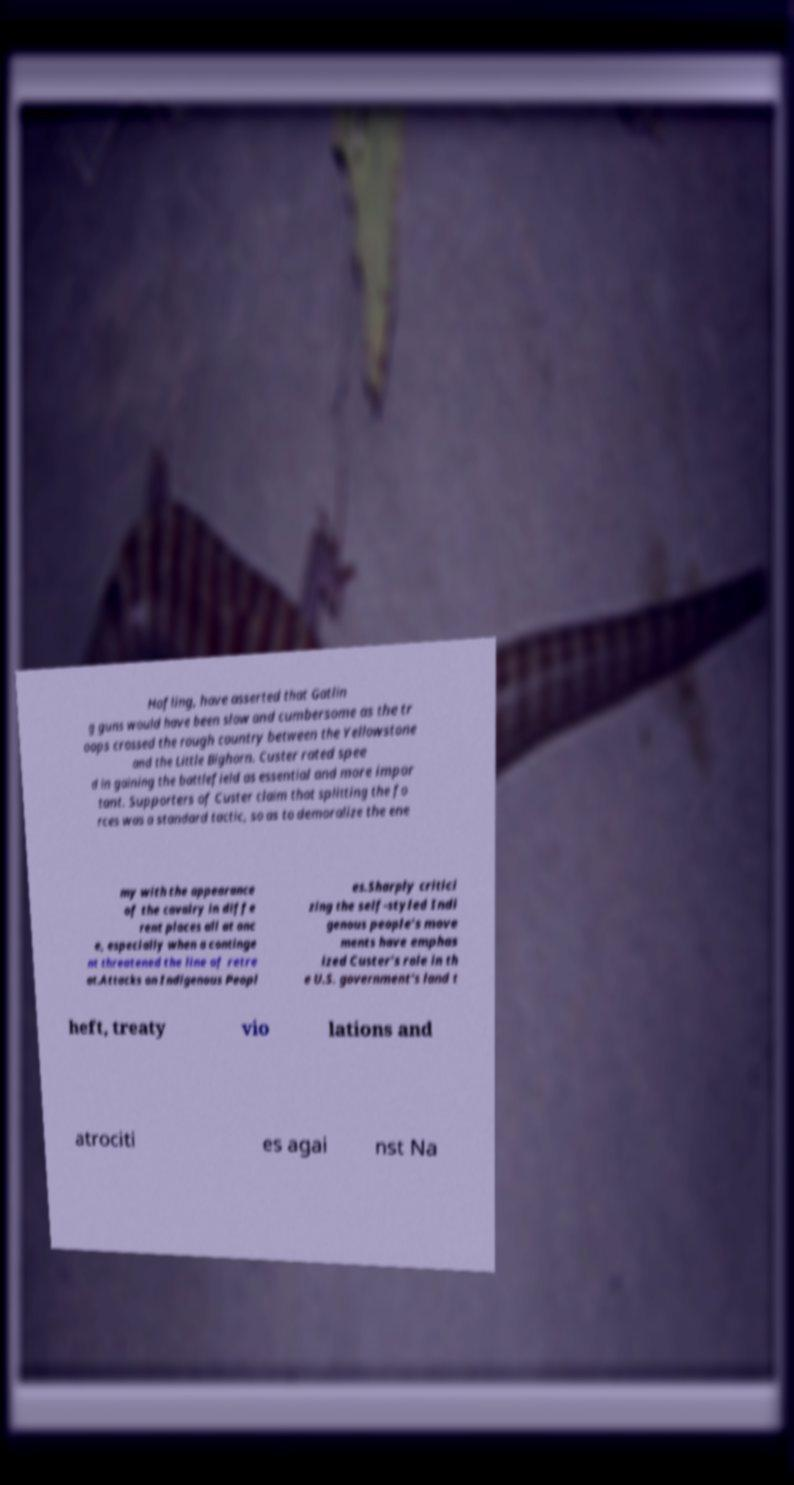For documentation purposes, I need the text within this image transcribed. Could you provide that? Hofling, have asserted that Gatlin g guns would have been slow and cumbersome as the tr oops crossed the rough country between the Yellowstone and the Little Bighorn. Custer rated spee d in gaining the battlefield as essential and more impor tant. Supporters of Custer claim that splitting the fo rces was a standard tactic, so as to demoralize the ene my with the appearance of the cavalry in diffe rent places all at onc e, especially when a continge nt threatened the line of retre at.Attacks on Indigenous Peopl es.Sharply critici zing the self-styled Indi genous people’s move ments have emphas ized Custer’s role in th e U.S. government’s land t heft, treaty vio lations and atrociti es agai nst Na 